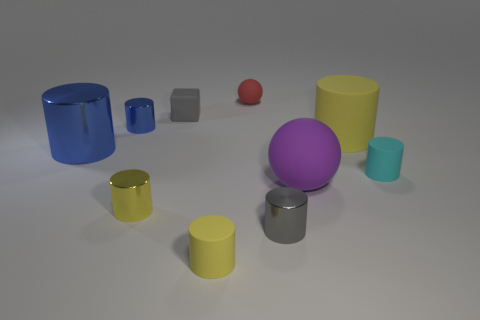Subtract all blue spheres. Subtract all cyan cylinders. How many spheres are left? 2 Subtract all red spheres. How many brown blocks are left? 0 Add 9 things. How many large browns exist? 0 Subtract all tiny matte spheres. Subtract all tiny red things. How many objects are left? 8 Add 9 tiny gray metallic cylinders. How many tiny gray metallic cylinders are left? 10 Add 1 small brown rubber cylinders. How many small brown rubber cylinders exist? 1 Subtract all gray cylinders. How many cylinders are left? 6 Subtract all cyan cylinders. How many cylinders are left? 6 Subtract 1 gray cylinders. How many objects are left? 9 How many yellow cylinders must be subtracted to get 2 yellow cylinders? 1 